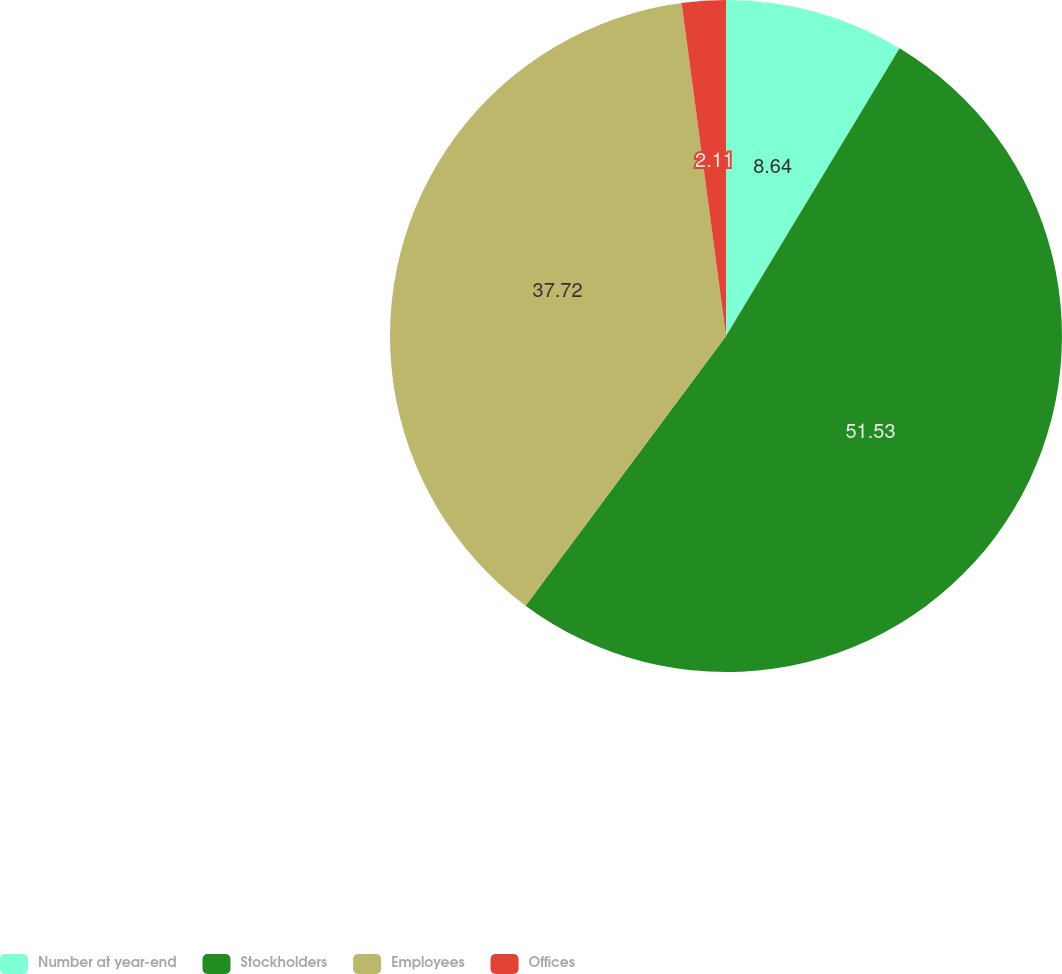<chart> <loc_0><loc_0><loc_500><loc_500><pie_chart><fcel>Number at year-end<fcel>Stockholders<fcel>Employees<fcel>Offices<nl><fcel>8.64%<fcel>51.54%<fcel>37.72%<fcel>2.11%<nl></chart> 